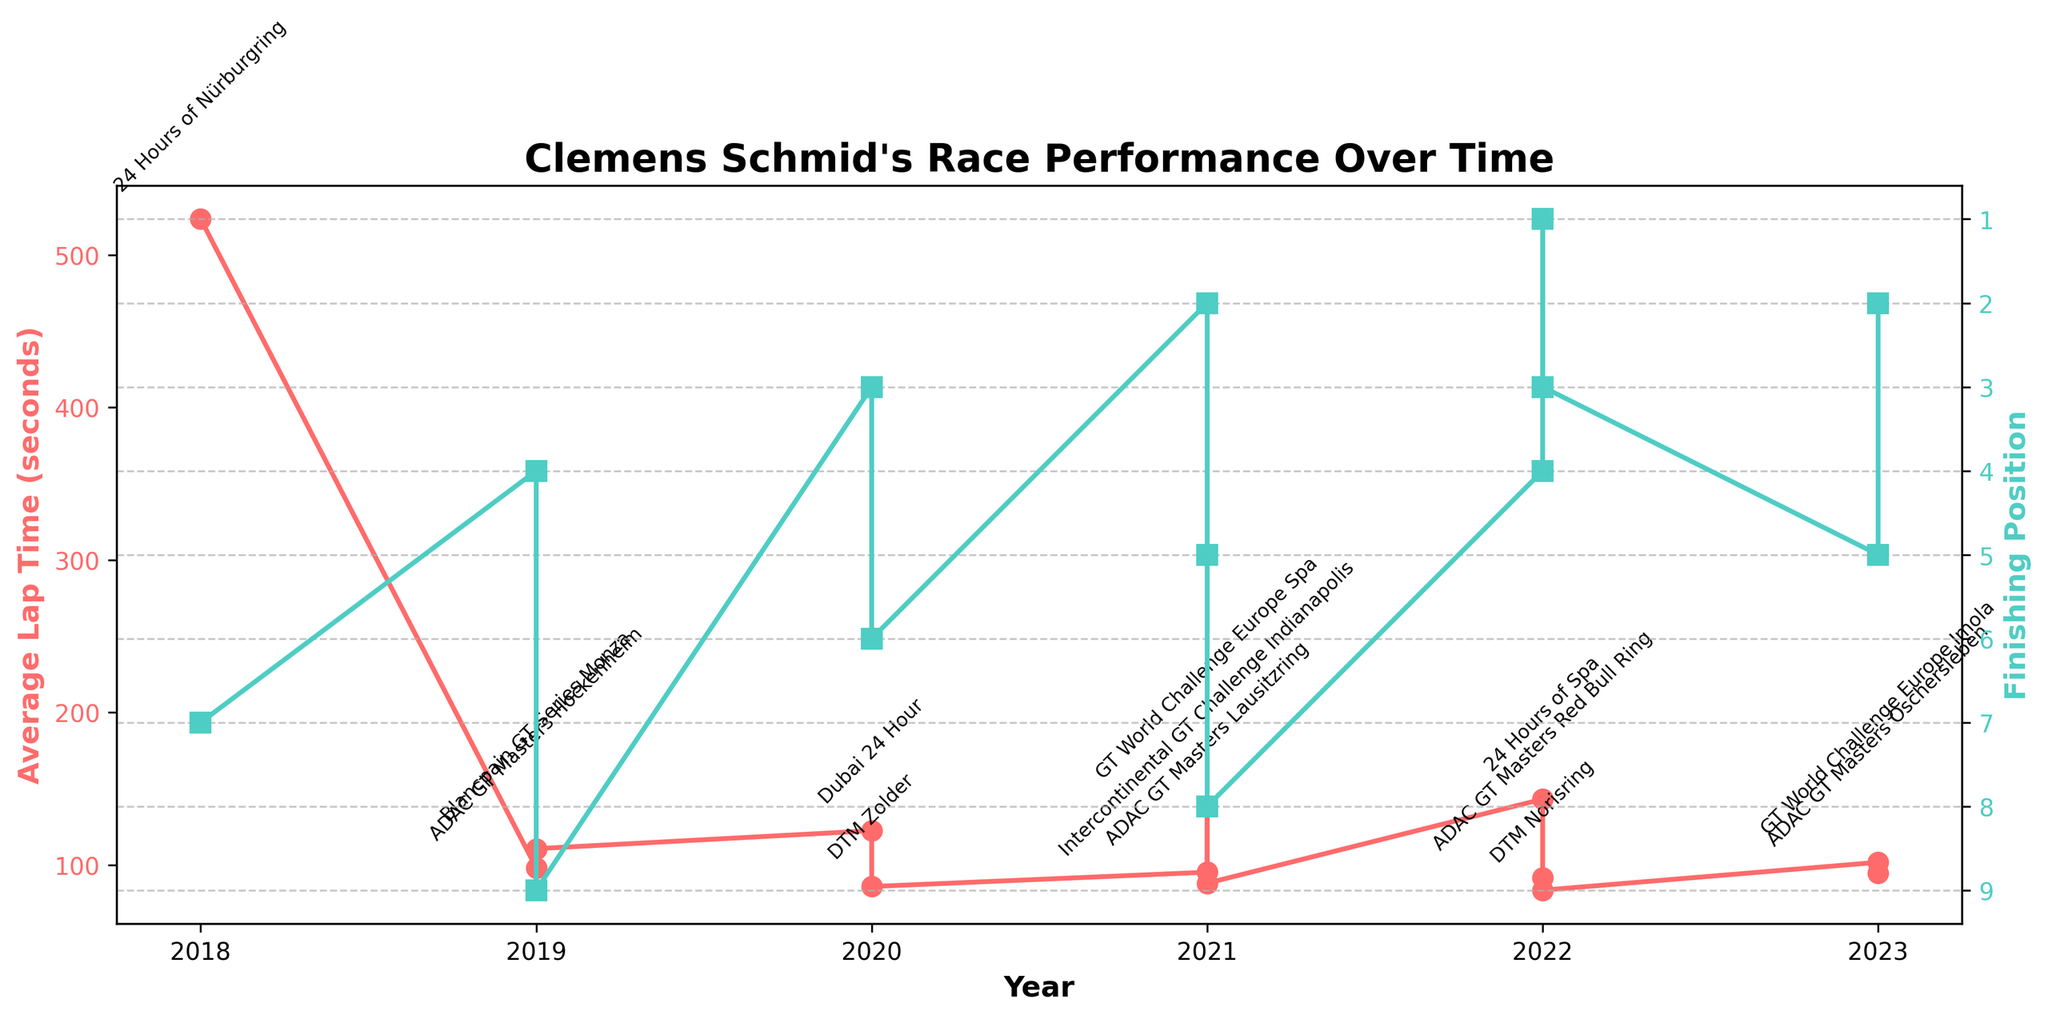How did Clemens Schmid's finishing position change from 2018 to 2022? To answer this, locate the finishing positions in 2018 and 2022 and compare them. In 2018, his position was 7th, and in 2022, it ranged between 1st and 4th. This indicates an improvement overall.
Answer: Improved In which year did Clemens Schmid have the lowest average lap time, and what was his finishing position that year? Find the year with the lowest lap time by checking the data. In 2022, during the DTM Norisring race, he had an average lap time of 83.5 seconds, and his finishing position was 3rd.
Answer: 2022, 3rd Between 2019 and 2020, did Clemens Schmid's average lap time improve, and if so, by how much? Compare the lap times in 2019 (98.2s, 110.7s) and 2020 (122.5s, 85.9s). Averaging the 2019 times gives (98.2 + 110.7) / 2 = 104.45s, and 2020's average is (122.5 + 85.9) / 2 = 104.2s. So, there's a minor improvement of 0.25s.
Answer: By 0.25 seconds Which race had the highest average lap time, and what was his finishing position in that race? Identify the highest lap time by reviewing the chart. The 2022 24 Hours of Spa had the highest average lap time of 143.2 seconds, and his finishing position was 4th.
Answer: 24 Hours of Spa, 4th What is the general trend in Clemens Schmid's average lap time from 2018 to 2023? Observe the overall pattern in the average lap times on the plot from 2018 to 2023. The trend shows some fluctuations, but there is no clear linear increase or decrease over time.
Answer: Fluctuating Which race did Clemens Schmid win, and what was his average lap time in that race? Look for the position graph where he finished 1st. In ADAC GT Masters Red Bull Ring in 2022, he won, and his average lap time was 91.7 seconds.
Answer: ADAC GT Masters Red Bull Ring, 91.7 seconds Did Clemens Schmid have more top 3 finishes in 2021 or 2022? Review the finishing positions for 2021 (2nd and 5th) and 2022 (1st, 3rd, and 4th). In 2022, he had 2 top 3 finishes, whereas in 2021, he had 1.
Answer: 2022 Considering the years 2021 and 2022, which year did Clemens Schmid have more races with a lap time under 100 seconds? Check the lap times for races in 2021 (95.3s, 138.6s, 88.1s) and 2022 (91.7s, 83.5s, 143.2s). In 2021, he had two races under 100 seconds, and in 2022, he had two as well.
Answer: Equal In the 2020 DTM Zolder race, how did Clemens Schmid's average lap time compare to the ADAC GT Masters Lausitzring race in 2021? Compare the specific lap times: 2020 DTM Zolder (85.9s) and 2021 ADAC GT Masters Lausitzring (95.3s). The 2020 DTM Zolder race had a faster average lap time.
Answer: Faster in DTM Zolder (2020) How many races did Clemens Schmid finish in the top 5 positions from 2018 to 2023? Count the positions that are 5 or better across all years: 2018 (1), 2019 (1), 2020 (1), 2021 (1), 2022 (3), and 2023 (1). Total is 8 races.
Answer: 8 